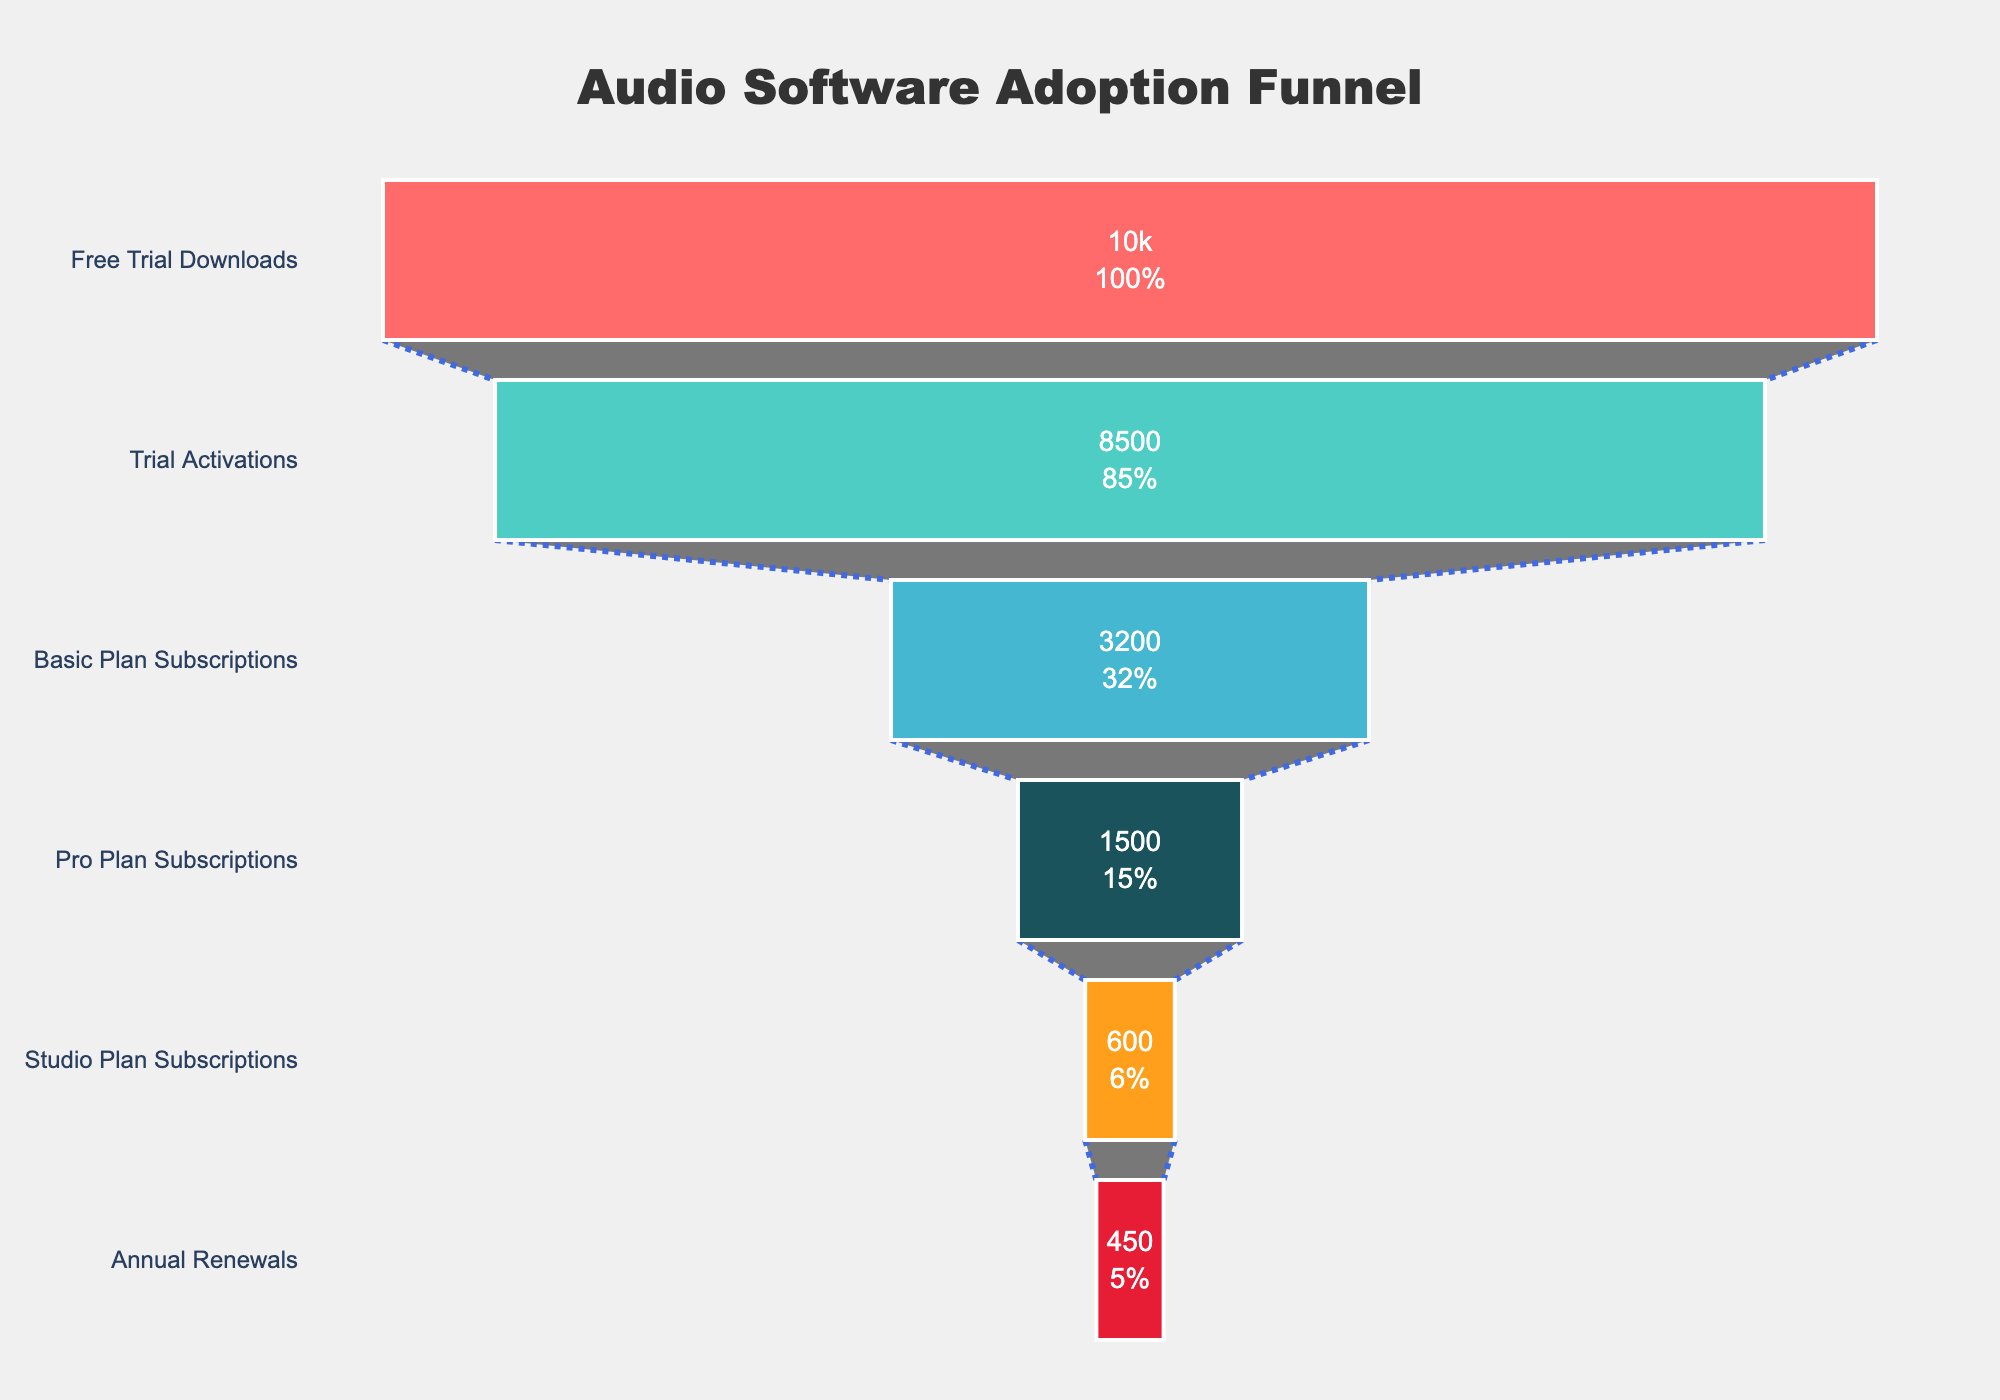What is the title of the chart? The title of the chart is displayed at the top of the chart. It reads "Audio Software Adoption Funnel."
Answer: Audio Software Adoption Funnel How many stages are represented in the funnel chart? The chart has multiple horizontal bars, each representing a stage. By counting them, we see there are six stages.
Answer: Six stages What percentage of users move from the Free Trial Downloads stage to the Trial Activations stage? The funnel chart shows a percentage label next to the Trial Activations stage. It shows the percentage of initial users from the Free Trial Downloads.
Answer: 85% How many users subscribed to the Pro Plan? The value next to the Pro Plan Subscriptions stage on the funnel chart represents the number of users for that stage. The number is 1,500.
Answer: 1,500 Which stage has the least number of users? By examining the lengths of the bars, the shortest bar corresponds to the stage with the least users, which is the Annual Renewals stage with 450 users.
Answer: Annual Renewals What is the difference in users between the Basic Plan Subscriptions and Studio Plan Subscriptions? Subtract the users of the Studio Plan Subscriptions (600) from the Basic Plan Subscriptions (3,200).
Answer: 2,600 What proportion of users who subscribed to the Basic Plan advance to the Pro Plan? Divide the users of the Pro Plan Subscriptions (1,500) by the users of the Basic Plan Subscriptions (3,200) to get approximately 46.88%.
Answer: Approximately 46.88% How many users do not renew annually from the Studio Plan Subscriptions? Subtract the Annual Renewals (450) from the Studio Plan Subscriptions (600) to find the number of users who do not renew annually.
Answer: 150 Which color represents the Trial Activations stage in the funnel chart? According to the order and the color scheme of the chart, the Trial Activations stage is represented in turquoise.
Answer: Turquoise How many users initiate but do not activate the trial? Subtract the Trial Activations (8,500) from the Free Trial Downloads (10,000) to find the number of users who do not activate the trial.
Answer: 1,500 